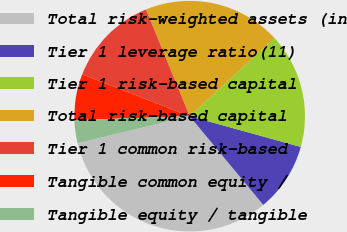Convert chart to OTSL. <chart><loc_0><loc_0><loc_500><loc_500><pie_chart><fcel>Total risk-weighted assets (in<fcel>Tier 1 leverage ratio(11)<fcel>Tier 1 risk-based capital<fcel>Total risk-based capital<fcel>Tier 1 common risk-based<fcel>Tangible common equity /<fcel>Tangible equity / tangible<nl><fcel>32.25%<fcel>9.68%<fcel>16.13%<fcel>19.35%<fcel>12.9%<fcel>6.45%<fcel>3.23%<nl></chart> 